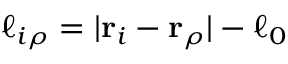Convert formula to latex. <formula><loc_0><loc_0><loc_500><loc_500>\ell _ { i \rho } = | { r } _ { i } - { r } _ { \rho } | - \ell _ { 0 }</formula> 